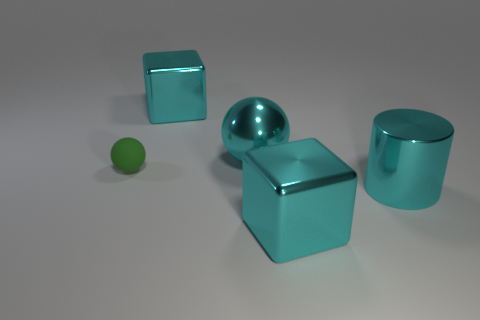Add 1 red spheres. How many objects exist? 6 Subtract all balls. How many objects are left? 3 Add 2 big green spheres. How many big green spheres exist? 2 Subtract 0 blue cubes. How many objects are left? 5 Subtract all cyan cylinders. Subtract all small rubber spheres. How many objects are left? 3 Add 5 cylinders. How many cylinders are left? 6 